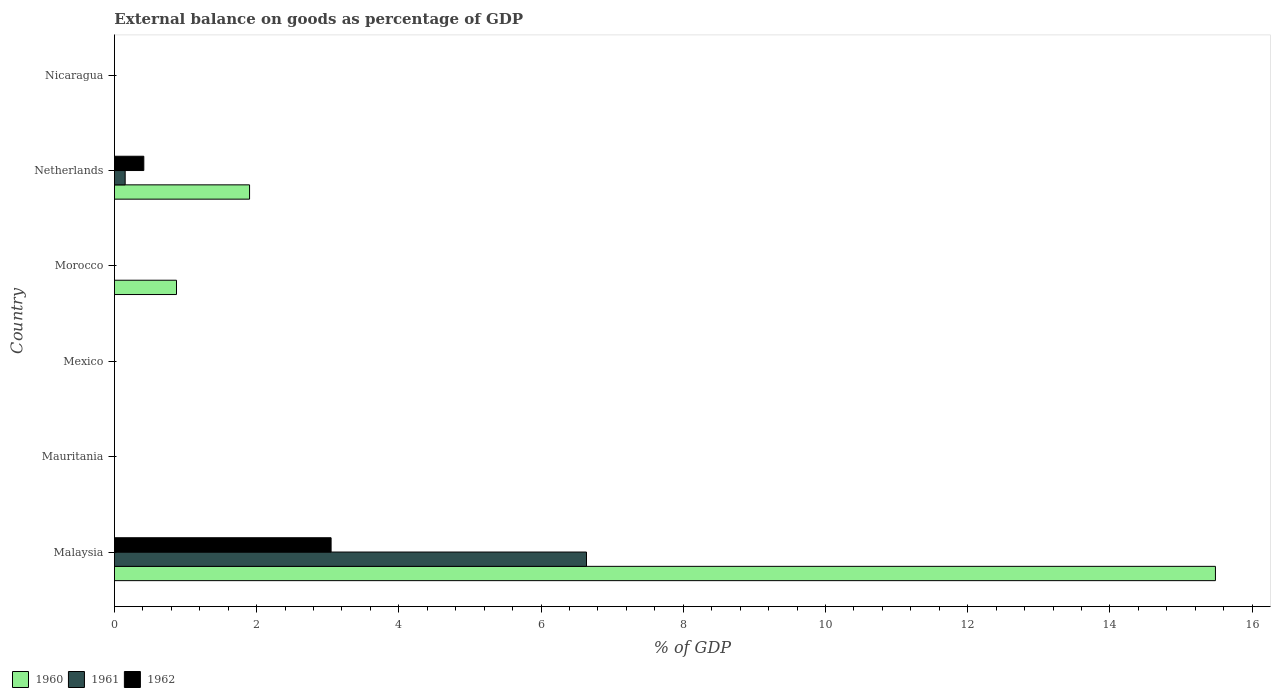Are the number of bars per tick equal to the number of legend labels?
Your answer should be very brief. No. Are the number of bars on each tick of the Y-axis equal?
Offer a terse response. No. How many bars are there on the 6th tick from the top?
Provide a short and direct response. 3. What is the label of the 1st group of bars from the top?
Keep it short and to the point. Nicaragua. Across all countries, what is the maximum external balance on goods as percentage of GDP in 1961?
Give a very brief answer. 6.64. Across all countries, what is the minimum external balance on goods as percentage of GDP in 1960?
Your answer should be compact. 0. In which country was the external balance on goods as percentage of GDP in 1962 maximum?
Your response must be concise. Malaysia. What is the total external balance on goods as percentage of GDP in 1962 in the graph?
Provide a short and direct response. 3.46. What is the difference between the external balance on goods as percentage of GDP in 1960 in Malaysia and that in Morocco?
Your answer should be compact. 14.61. What is the difference between the external balance on goods as percentage of GDP in 1960 in Malaysia and the external balance on goods as percentage of GDP in 1962 in Mexico?
Your answer should be very brief. 15.48. What is the average external balance on goods as percentage of GDP in 1961 per country?
Offer a very short reply. 1.13. What is the difference between the external balance on goods as percentage of GDP in 1962 and external balance on goods as percentage of GDP in 1961 in Malaysia?
Provide a succinct answer. -3.59. In how many countries, is the external balance on goods as percentage of GDP in 1962 greater than 12 %?
Your answer should be very brief. 0. What is the difference between the highest and the second highest external balance on goods as percentage of GDP in 1960?
Ensure brevity in your answer.  13.58. What is the difference between the highest and the lowest external balance on goods as percentage of GDP in 1960?
Provide a short and direct response. 15.48. In how many countries, is the external balance on goods as percentage of GDP in 1961 greater than the average external balance on goods as percentage of GDP in 1961 taken over all countries?
Offer a terse response. 1. How many countries are there in the graph?
Offer a terse response. 6. What is the difference between two consecutive major ticks on the X-axis?
Ensure brevity in your answer.  2. Does the graph contain any zero values?
Your answer should be very brief. Yes. Does the graph contain grids?
Ensure brevity in your answer.  No. How are the legend labels stacked?
Keep it short and to the point. Horizontal. What is the title of the graph?
Ensure brevity in your answer.  External balance on goods as percentage of GDP. What is the label or title of the X-axis?
Ensure brevity in your answer.  % of GDP. What is the % of GDP of 1960 in Malaysia?
Provide a succinct answer. 15.48. What is the % of GDP of 1961 in Malaysia?
Ensure brevity in your answer.  6.64. What is the % of GDP of 1962 in Malaysia?
Ensure brevity in your answer.  3.05. What is the % of GDP in 1960 in Mexico?
Give a very brief answer. 0. What is the % of GDP of 1961 in Mexico?
Provide a succinct answer. 0. What is the % of GDP of 1962 in Mexico?
Your response must be concise. 0. What is the % of GDP of 1960 in Morocco?
Your answer should be very brief. 0.87. What is the % of GDP in 1960 in Netherlands?
Your response must be concise. 1.9. What is the % of GDP in 1961 in Netherlands?
Provide a short and direct response. 0.15. What is the % of GDP of 1962 in Netherlands?
Your response must be concise. 0.41. Across all countries, what is the maximum % of GDP of 1960?
Make the answer very short. 15.48. Across all countries, what is the maximum % of GDP in 1961?
Give a very brief answer. 6.64. Across all countries, what is the maximum % of GDP in 1962?
Your answer should be very brief. 3.05. Across all countries, what is the minimum % of GDP in 1961?
Provide a short and direct response. 0. Across all countries, what is the minimum % of GDP in 1962?
Make the answer very short. 0. What is the total % of GDP in 1960 in the graph?
Provide a short and direct response. 18.26. What is the total % of GDP of 1961 in the graph?
Provide a short and direct response. 6.79. What is the total % of GDP in 1962 in the graph?
Your answer should be very brief. 3.46. What is the difference between the % of GDP of 1960 in Malaysia and that in Morocco?
Provide a succinct answer. 14.61. What is the difference between the % of GDP of 1960 in Malaysia and that in Netherlands?
Your answer should be very brief. 13.58. What is the difference between the % of GDP in 1961 in Malaysia and that in Netherlands?
Offer a very short reply. 6.49. What is the difference between the % of GDP in 1962 in Malaysia and that in Netherlands?
Your answer should be very brief. 2.63. What is the difference between the % of GDP in 1960 in Morocco and that in Netherlands?
Offer a very short reply. -1.03. What is the difference between the % of GDP in 1960 in Malaysia and the % of GDP in 1961 in Netherlands?
Provide a short and direct response. 15.33. What is the difference between the % of GDP of 1960 in Malaysia and the % of GDP of 1962 in Netherlands?
Give a very brief answer. 15.07. What is the difference between the % of GDP of 1961 in Malaysia and the % of GDP of 1962 in Netherlands?
Ensure brevity in your answer.  6.23. What is the difference between the % of GDP in 1960 in Morocco and the % of GDP in 1961 in Netherlands?
Your answer should be compact. 0.72. What is the difference between the % of GDP of 1960 in Morocco and the % of GDP of 1962 in Netherlands?
Make the answer very short. 0.46. What is the average % of GDP in 1960 per country?
Offer a terse response. 3.04. What is the average % of GDP of 1961 per country?
Keep it short and to the point. 1.13. What is the average % of GDP of 1962 per country?
Your answer should be very brief. 0.58. What is the difference between the % of GDP of 1960 and % of GDP of 1961 in Malaysia?
Your answer should be compact. 8.85. What is the difference between the % of GDP of 1960 and % of GDP of 1962 in Malaysia?
Ensure brevity in your answer.  12.44. What is the difference between the % of GDP of 1961 and % of GDP of 1962 in Malaysia?
Provide a succinct answer. 3.59. What is the difference between the % of GDP of 1960 and % of GDP of 1961 in Netherlands?
Keep it short and to the point. 1.75. What is the difference between the % of GDP of 1960 and % of GDP of 1962 in Netherlands?
Provide a short and direct response. 1.49. What is the difference between the % of GDP of 1961 and % of GDP of 1962 in Netherlands?
Your response must be concise. -0.26. What is the ratio of the % of GDP of 1960 in Malaysia to that in Morocco?
Your answer should be very brief. 17.74. What is the ratio of the % of GDP in 1960 in Malaysia to that in Netherlands?
Offer a terse response. 8.15. What is the ratio of the % of GDP of 1961 in Malaysia to that in Netherlands?
Provide a succinct answer. 43.97. What is the ratio of the % of GDP of 1962 in Malaysia to that in Netherlands?
Keep it short and to the point. 7.37. What is the ratio of the % of GDP of 1960 in Morocco to that in Netherlands?
Make the answer very short. 0.46. What is the difference between the highest and the second highest % of GDP in 1960?
Your answer should be compact. 13.58. What is the difference between the highest and the lowest % of GDP in 1960?
Your answer should be compact. 15.48. What is the difference between the highest and the lowest % of GDP of 1961?
Ensure brevity in your answer.  6.64. What is the difference between the highest and the lowest % of GDP in 1962?
Your response must be concise. 3.05. 